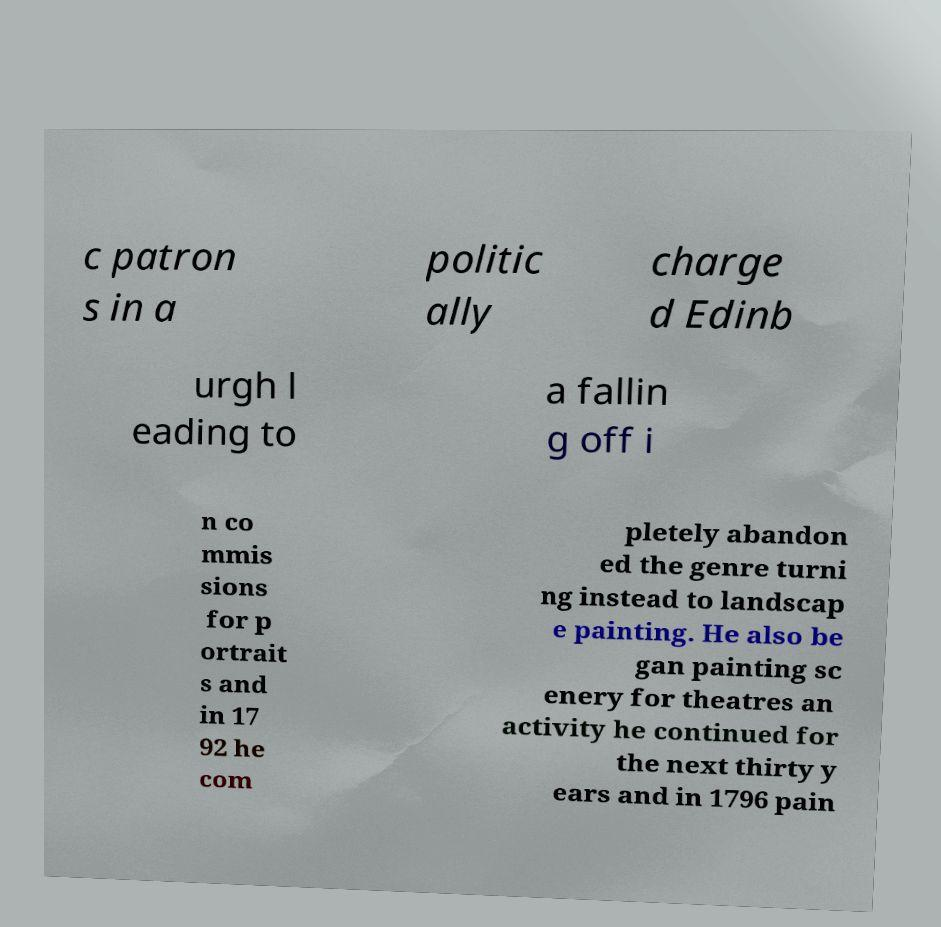Can you read and provide the text displayed in the image?This photo seems to have some interesting text. Can you extract and type it out for me? c patron s in a politic ally charge d Edinb urgh l eading to a fallin g off i n co mmis sions for p ortrait s and in 17 92 he com pletely abandon ed the genre turni ng instead to landscap e painting. He also be gan painting sc enery for theatres an activity he continued for the next thirty y ears and in 1796 pain 